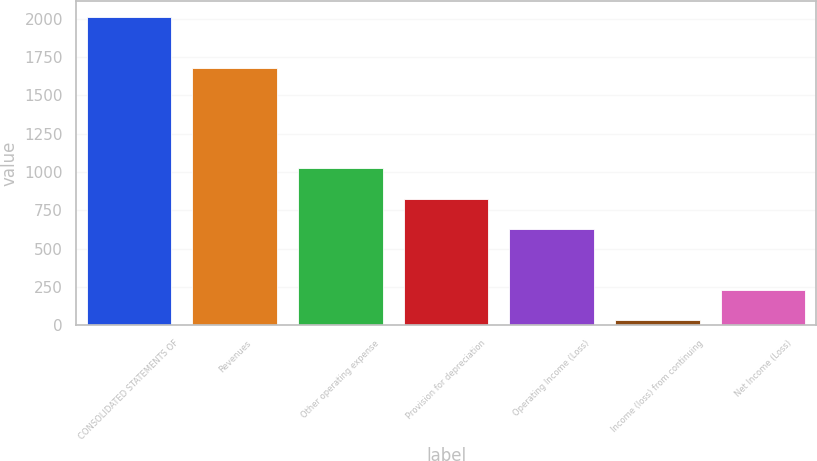<chart> <loc_0><loc_0><loc_500><loc_500><bar_chart><fcel>CONSOLIDATED STATEMENTS OF<fcel>Revenues<fcel>Other operating expense<fcel>Provision for depreciation<fcel>Operating Income (Loss)<fcel>Income (loss) from continuing<fcel>Net Income (Loss)<nl><fcel>2013<fcel>1679<fcel>1023<fcel>825<fcel>627<fcel>33<fcel>231<nl></chart> 